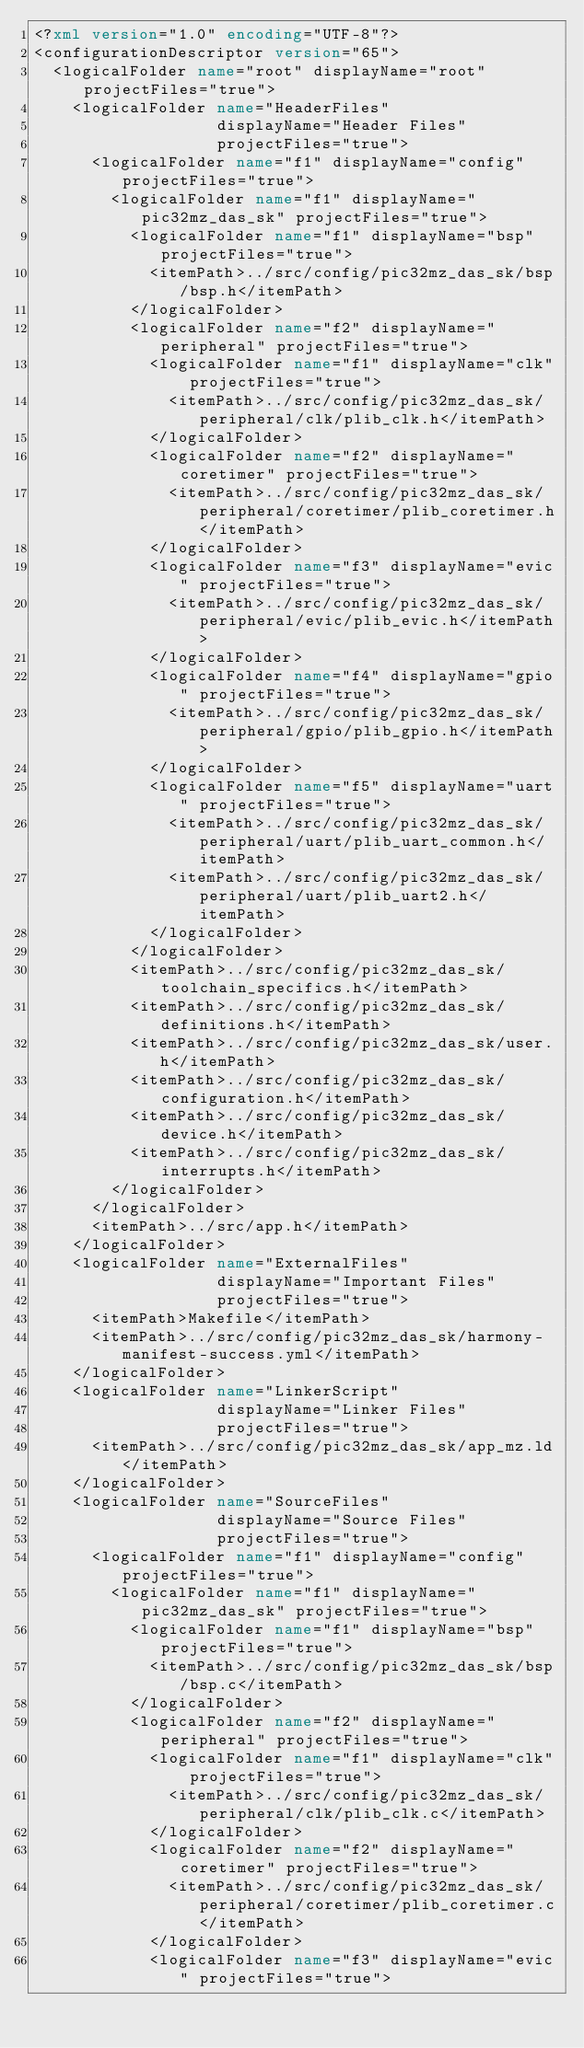<code> <loc_0><loc_0><loc_500><loc_500><_XML_><?xml version="1.0" encoding="UTF-8"?>
<configurationDescriptor version="65">
  <logicalFolder name="root" displayName="root" projectFiles="true">
    <logicalFolder name="HeaderFiles"
                   displayName="Header Files"
                   projectFiles="true">
      <logicalFolder name="f1" displayName="config" projectFiles="true">
        <logicalFolder name="f1" displayName="pic32mz_das_sk" projectFiles="true">
          <logicalFolder name="f1" displayName="bsp" projectFiles="true">
            <itemPath>../src/config/pic32mz_das_sk/bsp/bsp.h</itemPath>
          </logicalFolder>
          <logicalFolder name="f2" displayName="peripheral" projectFiles="true">
            <logicalFolder name="f1" displayName="clk" projectFiles="true">
              <itemPath>../src/config/pic32mz_das_sk/peripheral/clk/plib_clk.h</itemPath>
            </logicalFolder>
            <logicalFolder name="f2" displayName="coretimer" projectFiles="true">
              <itemPath>../src/config/pic32mz_das_sk/peripheral/coretimer/plib_coretimer.h</itemPath>
            </logicalFolder>
            <logicalFolder name="f3" displayName="evic" projectFiles="true">
              <itemPath>../src/config/pic32mz_das_sk/peripheral/evic/plib_evic.h</itemPath>
            </logicalFolder>
            <logicalFolder name="f4" displayName="gpio" projectFiles="true">
              <itemPath>../src/config/pic32mz_das_sk/peripheral/gpio/plib_gpio.h</itemPath>
            </logicalFolder>
            <logicalFolder name="f5" displayName="uart" projectFiles="true">
              <itemPath>../src/config/pic32mz_das_sk/peripheral/uart/plib_uart_common.h</itemPath>
              <itemPath>../src/config/pic32mz_das_sk/peripheral/uart/plib_uart2.h</itemPath>
            </logicalFolder>
          </logicalFolder>
          <itemPath>../src/config/pic32mz_das_sk/toolchain_specifics.h</itemPath>
          <itemPath>../src/config/pic32mz_das_sk/definitions.h</itemPath>
          <itemPath>../src/config/pic32mz_das_sk/user.h</itemPath>
          <itemPath>../src/config/pic32mz_das_sk/configuration.h</itemPath>
          <itemPath>../src/config/pic32mz_das_sk/device.h</itemPath>
          <itemPath>../src/config/pic32mz_das_sk/interrupts.h</itemPath>
        </logicalFolder>
      </logicalFolder>
      <itemPath>../src/app.h</itemPath>
    </logicalFolder>
    <logicalFolder name="ExternalFiles"
                   displayName="Important Files"
                   projectFiles="true">
      <itemPath>Makefile</itemPath>
      <itemPath>../src/config/pic32mz_das_sk/harmony-manifest-success.yml</itemPath>
    </logicalFolder>
    <logicalFolder name="LinkerScript"
                   displayName="Linker Files"
                   projectFiles="true">
      <itemPath>../src/config/pic32mz_das_sk/app_mz.ld</itemPath>
    </logicalFolder>
    <logicalFolder name="SourceFiles"
                   displayName="Source Files"
                   projectFiles="true">
      <logicalFolder name="f1" displayName="config" projectFiles="true">
        <logicalFolder name="f1" displayName="pic32mz_das_sk" projectFiles="true">
          <logicalFolder name="f1" displayName="bsp" projectFiles="true">
            <itemPath>../src/config/pic32mz_das_sk/bsp/bsp.c</itemPath>
          </logicalFolder>
          <logicalFolder name="f2" displayName="peripheral" projectFiles="true">
            <logicalFolder name="f1" displayName="clk" projectFiles="true">
              <itemPath>../src/config/pic32mz_das_sk/peripheral/clk/plib_clk.c</itemPath>
            </logicalFolder>
            <logicalFolder name="f2" displayName="coretimer" projectFiles="true">
              <itemPath>../src/config/pic32mz_das_sk/peripheral/coretimer/plib_coretimer.c</itemPath>
            </logicalFolder>
            <logicalFolder name="f3" displayName="evic" projectFiles="true"></code> 